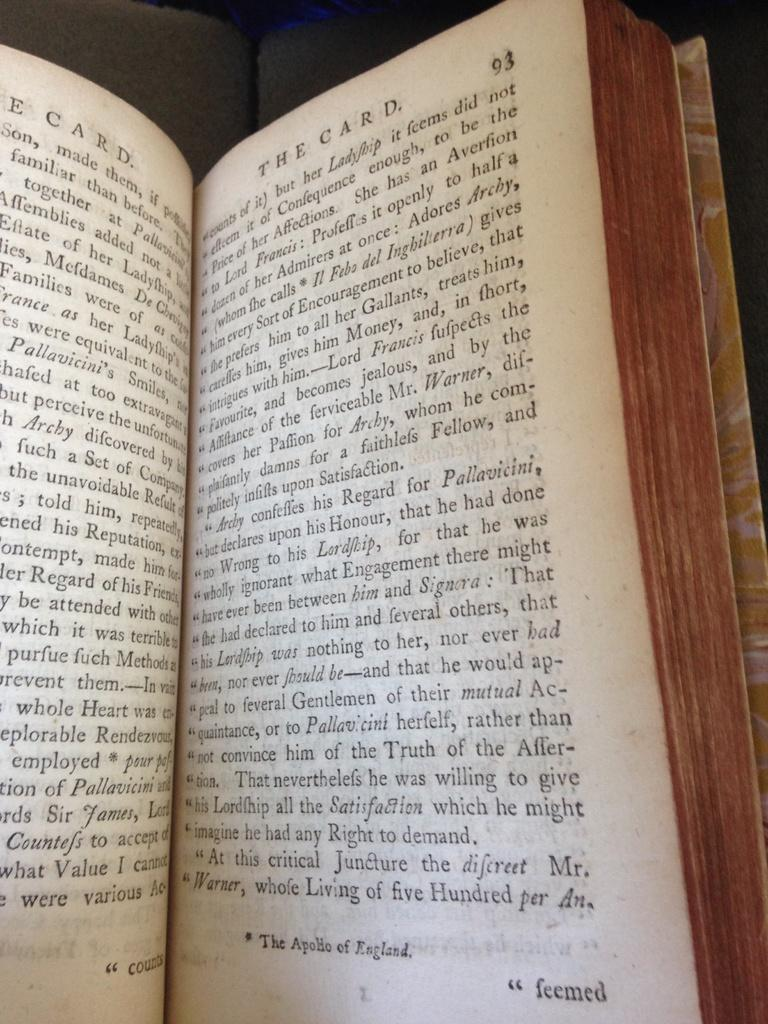<image>
Offer a succinct explanation of the picture presented. A book called "The Card" is open to page 93. 